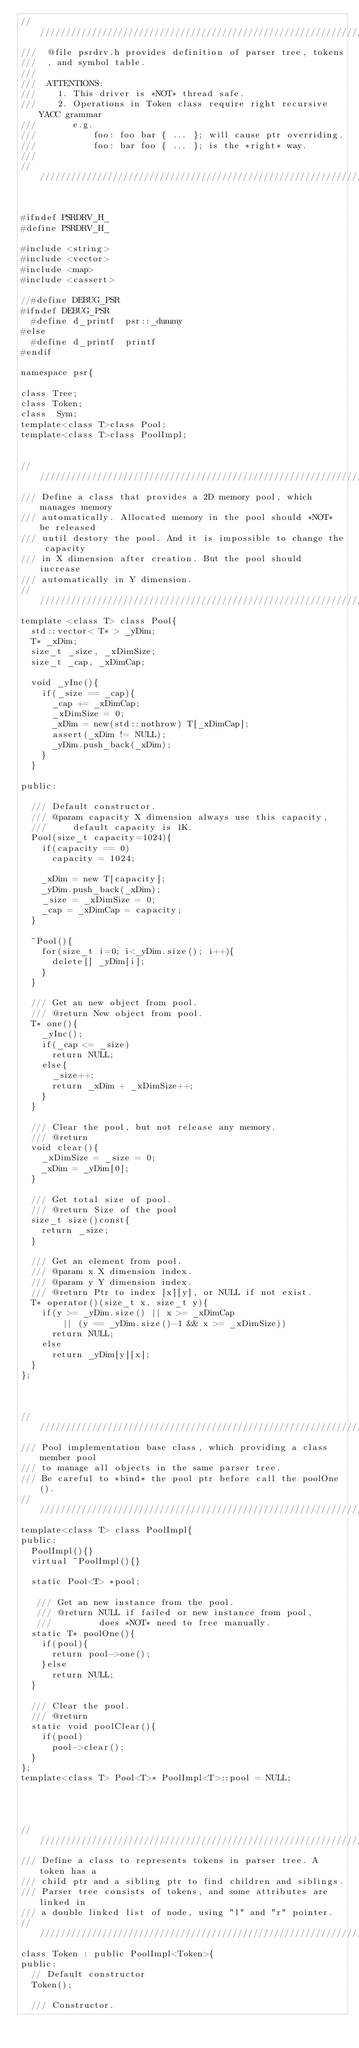<code> <loc_0><loc_0><loc_500><loc_500><_C_>/////////////////////////////////////////////////////////////////////
///  @file psrdrv.h provides definition of parser tree, tokens
///  , and symbol table.
///
///  ATTENTIONS:
///    1. This driver is *NOT* thread safe.
///    2. Operations in Token class require right recursive YACC grammar
///       e.g. 
///           foo: foo bar { ... }; will cause ptr overriding.
///           foo: bar foo { ... }; is the *right* way.
///
/////////////////////////////////////////////////////////////////////


#ifndef PSRDRV_H_
#define PSRDRV_H_

#include <string>
#include <vector>
#include <map>
#include <cassert>

//#define DEBUG_PSR
#ifndef DEBUG_PSR
  #define d_printf  psr::_dummy
#else
  #define d_printf  printf
#endif

namespace psr{

class Tree;
class Token;
class  Sym;
template<class T>class Pool;
template<class T>class PoolImpl;


/////////////////////////////////////////////////////////////////////////
/// Define a class that provides a 2D memory pool, which manages memory
/// automatically. Allocated memory in the pool should *NOT* be released 
/// until destory the pool. And it is impossible to change the capacity 
/// in X dimension after creation. But the pool should increase 
/// automatically in Y dimension.
////////////////////////////////////////////////////////////////////////
template <class T> class Pool{
  std::vector< T* > _yDim;
  T* _xDim;
  size_t _size, _xDimSize;
  size_t _cap, _xDimCap;

  void _yInc(){
    if(_size == _cap){
      _cap += _xDimCap;
      _xDimSize = 0;
      _xDim = new(std::nothrow) T[_xDimCap];
      assert(_xDim != NULL);
      _yDim.push_back(_xDim);
    }
  }

public:

  /// Default constructor.
  /// @param capacity X dimension always use this capacity, 
  ///     default capacity is 1K.
  Pool(size_t capacity=1024){
    if(capacity == 0)
      capacity = 1024;

    _xDim = new T[capacity];
    _yDim.push_back(_xDim);
    _size = _xDimSize = 0;
    _cap = _xDimCap = capacity;
  }
  
  ~Pool(){
    for(size_t i=0; i<_yDim.size(); i++){
      delete[] _yDim[i];
    }
  }
  
  /// Get an new object from pool.
  /// @return New object from pool.
  T* one(){
    _yInc();
    if(_cap <= _size)
      return NULL;
    else{
      _size++;
      return _xDim + _xDimSize++;
    }
  }

  /// Clear the pool, but not release any memory.
  /// @return
  void clear(){
    _xDimSize = _size = 0;
    _xDim = _yDim[0];
  }
  
  /// Get total size of pool.
  /// @return Size of the pool
  size_t size()const{
    return _size;
  }
  
  /// Get an element from pool.
  /// @param x X dimension index.
  /// @param y Y dimension index.
  /// @return Ptr to index [x][y], or NULL if not exist.
  T* operator()(size_t x, size_t y){
    if(y >= _yDim.size() || x >= _xDimCap
        || (y == _yDim.size()-1 && x >= _xDimSize))
      return NULL;
    else
      return _yDim[y][x];
  }
};



///////////////////////////////////////////////////////////////////
/// Pool implementation base class, which providing a class member pool 
/// to manage all objects in the same parser tree.
/// Be careful to *bind* the pool ptr before call the poolOne().
//////////////////////////////////////////////////////////////////
template<class T> class PoolImpl{
public:
  PoolImpl(){}
  virtual ~PoolImpl(){}

  static Pool<T> *pool;

   /// Get an new instance from the pool.
   /// @return NULL if failed or new instance from pool,
   ///         does *NOT* need to free manually.
  static T* poolOne(){
    if(pool){
      return pool->one();
    }else
      return NULL;
  }

  /// Clear the pool.
  /// @return
  static void poolClear(){
    if(pool)
      pool->clear();
  }
};
template<class T> Pool<T>* PoolImpl<T>::pool = NULL;




////////////////////////////////////////////////////////////////////////
/// Define a class to represents tokens in parser tree. A token has a 
/// child ptr and a sibling ptr to find children and siblings.
/// Parser tree consists of tokens, and some attributes are linked in
/// a double linked list of node, using "l" and "r" pointer.
////////////////////////////////////////////////////////////////////////
class Token : public PoolImpl<Token>{
public:
  // Default constructor
  Token();

  /// Constructor.</code> 